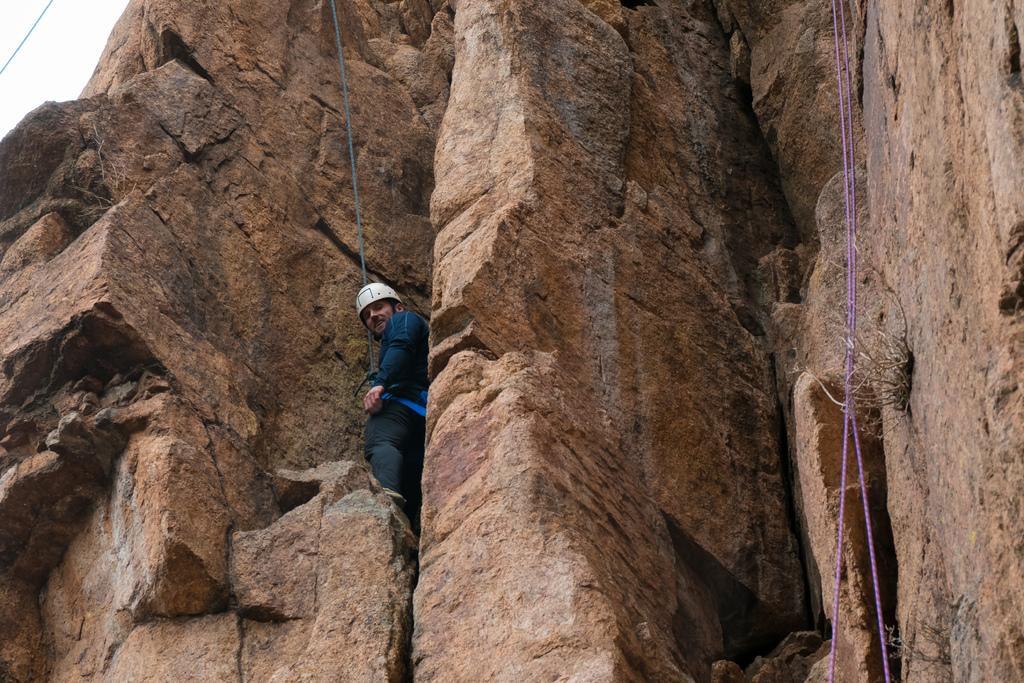Please provide a concise description of this image. In this image we can see a mountaineer who is wearing helmet which is white in color and he is tied with a rope and there are some ropes on left and right side of the image and there is rock. 